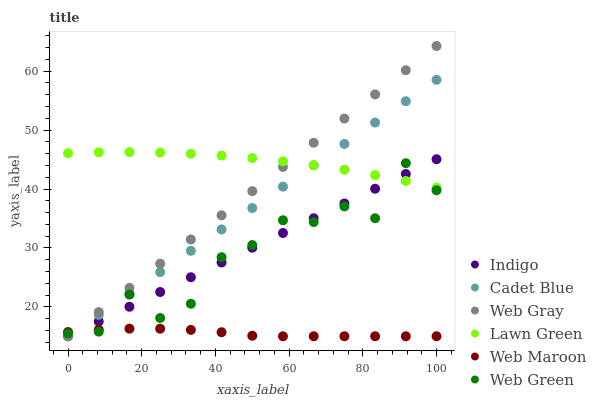Does Web Maroon have the minimum area under the curve?
Answer yes or no. Yes. Does Lawn Green have the maximum area under the curve?
Answer yes or no. Yes. Does Web Gray have the minimum area under the curve?
Answer yes or no. No. Does Web Gray have the maximum area under the curve?
Answer yes or no. No. Is Web Gray the smoothest?
Answer yes or no. Yes. Is Web Green the roughest?
Answer yes or no. Yes. Is Indigo the smoothest?
Answer yes or no. No. Is Indigo the roughest?
Answer yes or no. No. Does Web Gray have the lowest value?
Answer yes or no. Yes. Does Web Green have the lowest value?
Answer yes or no. No. Does Web Gray have the highest value?
Answer yes or no. Yes. Does Indigo have the highest value?
Answer yes or no. No. Is Web Maroon less than Lawn Green?
Answer yes or no. Yes. Is Lawn Green greater than Web Maroon?
Answer yes or no. Yes. Does Cadet Blue intersect Web Gray?
Answer yes or no. Yes. Is Cadet Blue less than Web Gray?
Answer yes or no. No. Is Cadet Blue greater than Web Gray?
Answer yes or no. No. Does Web Maroon intersect Lawn Green?
Answer yes or no. No. 